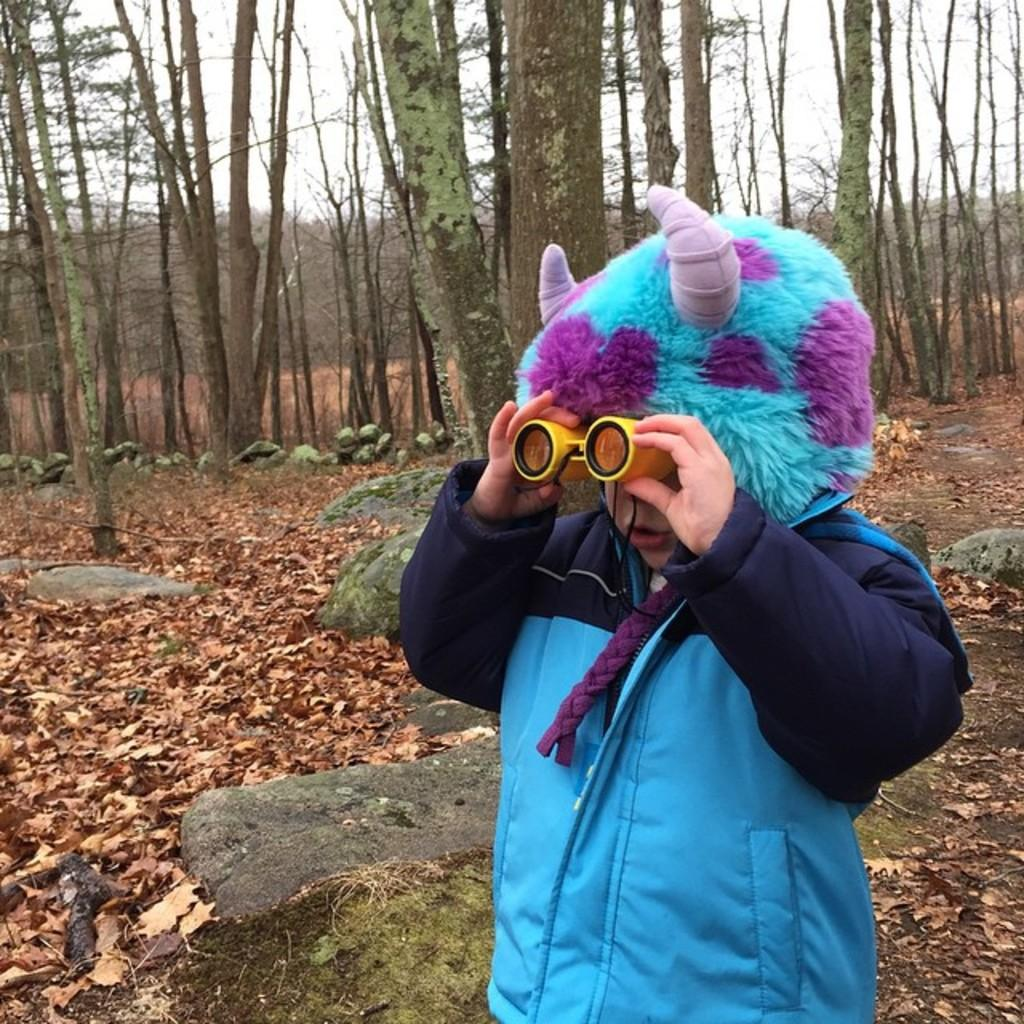What is the main subject of the image? There is a kid standing in the image. What is the kid holding in the image? The kid is holding a yellow object. What can be seen on the ground in the image? There are dried leaves on the ground. What type of natural environment is visible in the image? There are trees and the sky visible in the image. How does the kid sort the milk in the image? There is no milk present in the image, so the kid cannot sort any milk. 